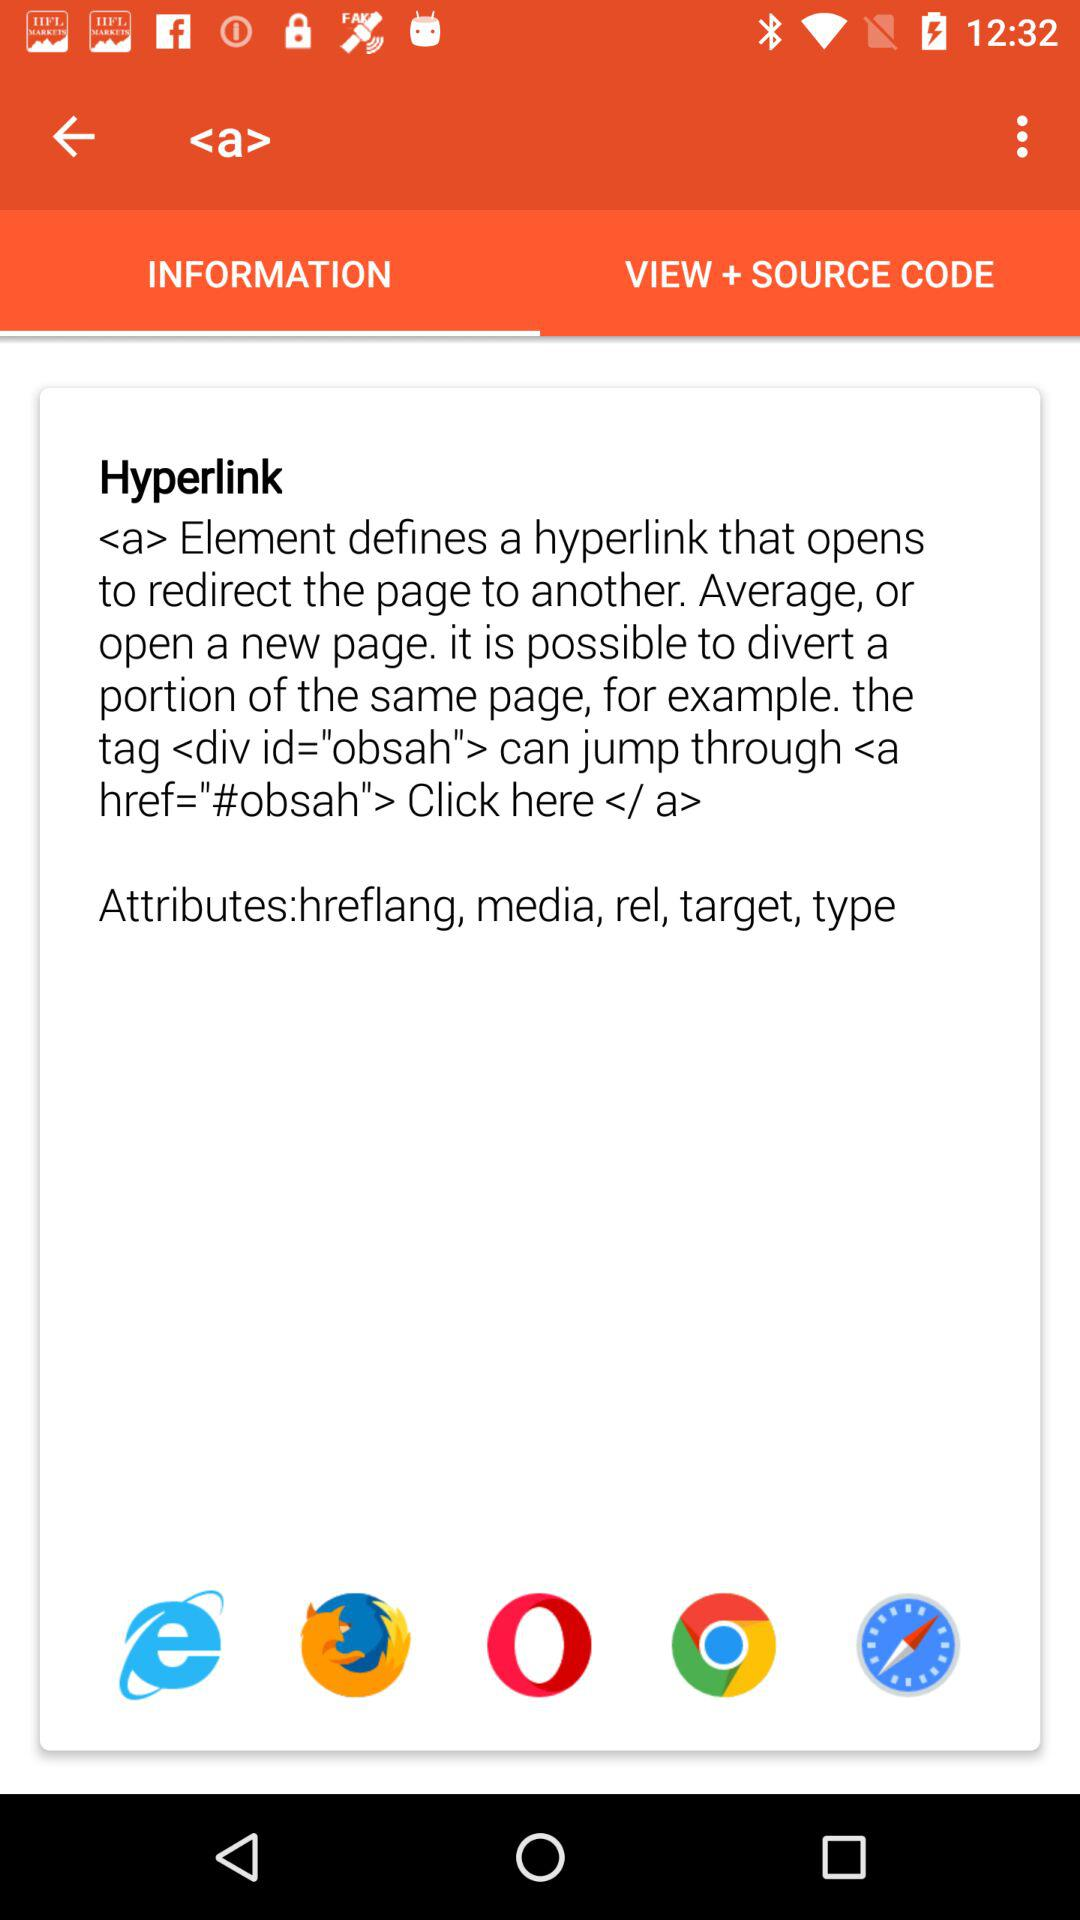Which tab is selected? The selected tab is "INFORMATION". 